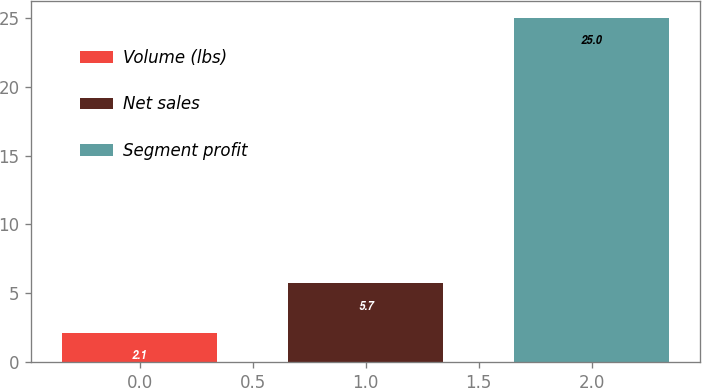Convert chart to OTSL. <chart><loc_0><loc_0><loc_500><loc_500><bar_chart><fcel>Volume (lbs)<fcel>Net sales<fcel>Segment profit<nl><fcel>2.1<fcel>5.7<fcel>25<nl></chart> 